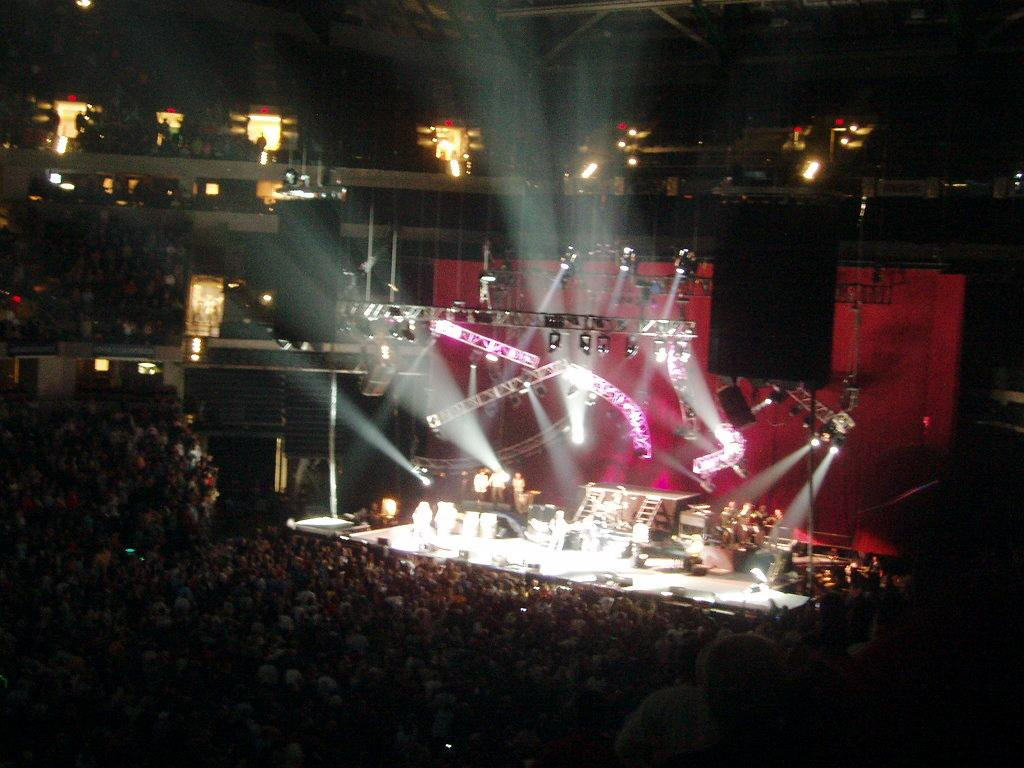What is the main subject of the image? The main subject of the image is groups of people. Can you describe the lighting conditions in the image? The image is a little dark, but there are lights visible. How far away from the shore is the notebook floating in the image? There is no notebook or ocean present in the image, so this question cannot be answered. 